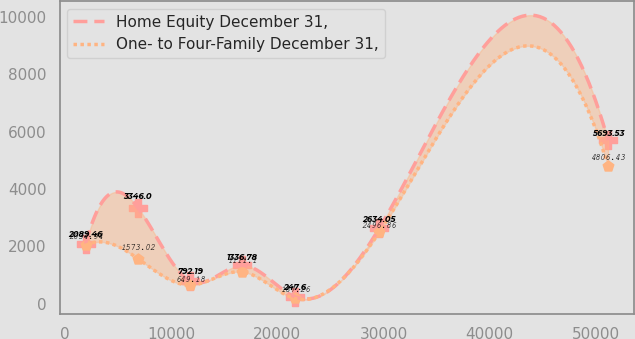Convert chart to OTSL. <chart><loc_0><loc_0><loc_500><loc_500><line_chart><ecel><fcel>Home Equity December 31,<fcel>One- to Four-Family December 31,<nl><fcel>1938.75<fcel>2089.46<fcel>2034.94<nl><fcel>6858.84<fcel>3346<fcel>1573.02<nl><fcel>11778.9<fcel>792.19<fcel>649.18<nl><fcel>16699<fcel>1336.78<fcel>1111.1<nl><fcel>21619.1<fcel>247.6<fcel>187.26<nl><fcel>29594.1<fcel>2634.05<fcel>2496.86<nl><fcel>51139.6<fcel>5693.53<fcel>4806.43<nl></chart> 